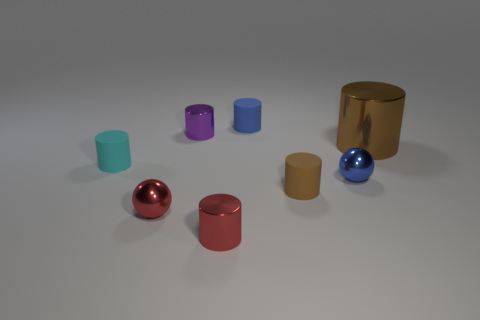Subtract 2 cylinders. How many cylinders are left? 4 Subtract all red cylinders. How many cylinders are left? 5 Subtract all small cyan rubber cylinders. How many cylinders are left? 5 Subtract all green cylinders. Subtract all green spheres. How many cylinders are left? 6 Add 2 blue objects. How many objects exist? 10 Subtract all spheres. How many objects are left? 6 Subtract all blue cylinders. Subtract all brown cylinders. How many objects are left? 5 Add 1 red things. How many red things are left? 3 Add 3 blue shiny spheres. How many blue shiny spheres exist? 4 Subtract 0 red cubes. How many objects are left? 8 